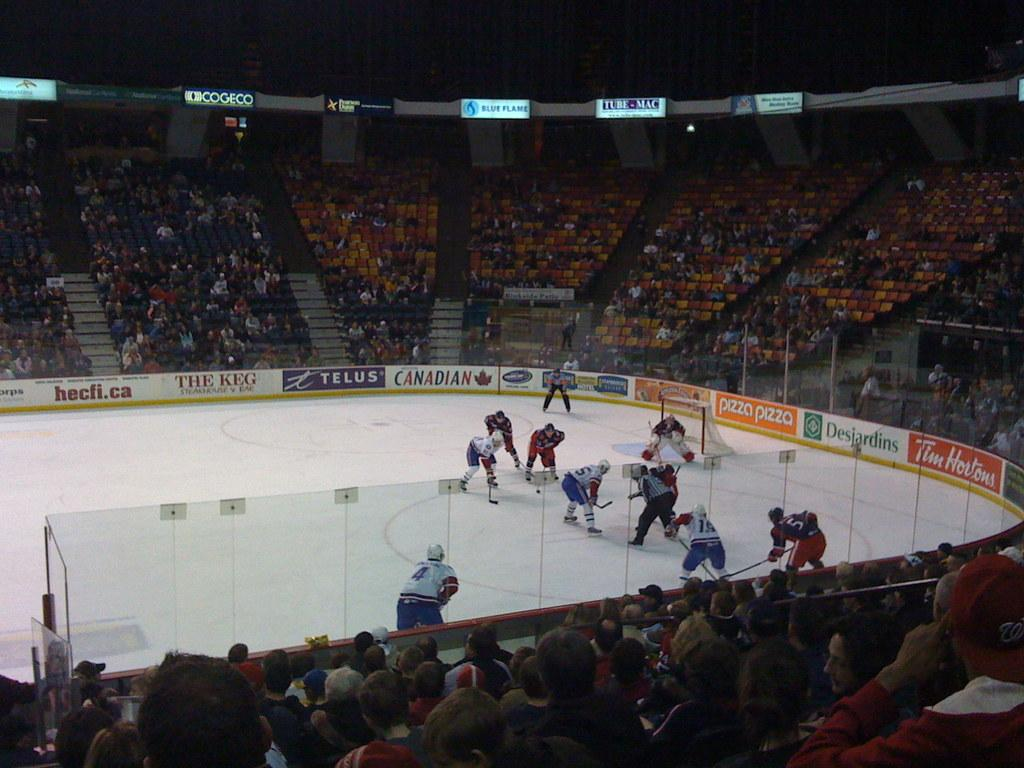What sport are the people playing in the image? The people are playing hockey in the image. What can be seen in the background of the image? There is a crowd and seats visible in the background of the image. What separates the playing area from the crowd in the image? There are boards at the top of the image. What type of building is visible in the image? There is no building visible in the image; it features people playing hockey on a rink with boards separating the playing area from the crowd. --- Facts: 1. There is a person holding a book in the image. 2. The person is sitting on a chair. 3. There is a table next to the chair. 4. The book has a blue cover. 5. The chair has a cushion. Absurd Topics: dog, ocean, mountain Conversation: What is the person in the image holding? The person is holding a book in the image. What is the person's position in the image? The person is sitting on a chair in the image. What is located next to the chair? There is a table next to the chair in the image. What is the color of the book's cover? The book has a blue cover in the image. What is the chair's condition? The chair has a cushion in the image. Reasoning: Let's think step by step in order to produce the conversation. We start by identifying the main subject in the image, which is the person holding a book. Then, we expand the conversation to include other elements that are also visible, such as the chair, table, and the book's cover color. Each question is designed to elicit a specific detail about the image that is known from the provided facts. Absurd Question/Answer: Can you see a dog playing in the ocean in the image? There is no dog or ocean present in the image; it features a person sitting on a chair holding 